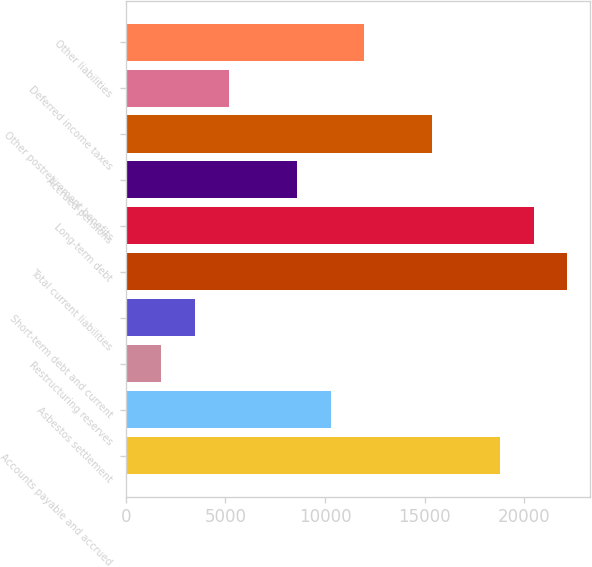<chart> <loc_0><loc_0><loc_500><loc_500><bar_chart><fcel>Accounts payable and accrued<fcel>Asbestos settlement<fcel>Restructuring reserves<fcel>Short-term debt and current<fcel>Total current liabilities<fcel>Long-term debt<fcel>Accrued pensions<fcel>Other postretirement benefits<fcel>Deferred income taxes<fcel>Other liabilities<nl><fcel>18775<fcel>10280<fcel>1785<fcel>3484<fcel>22173<fcel>20474<fcel>8581<fcel>15377<fcel>5183<fcel>11979<nl></chart> 